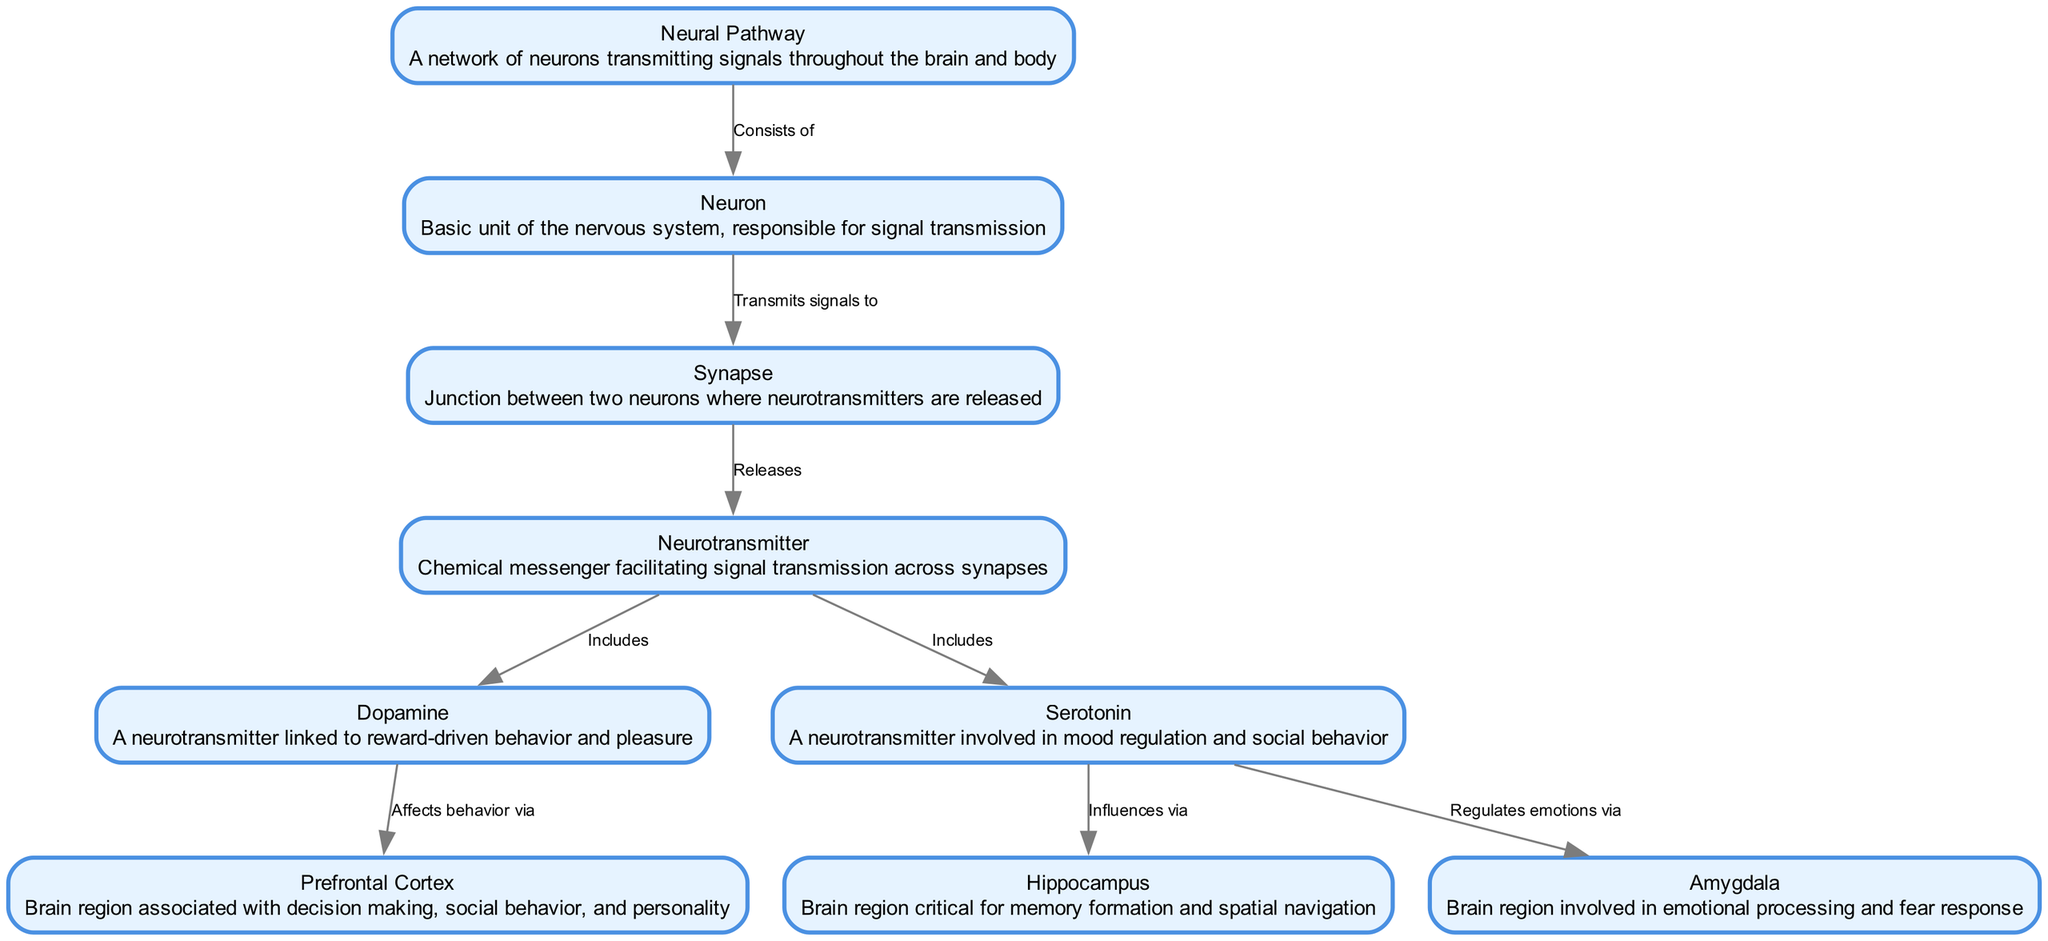What are the types of neurotransmitters mentioned in the diagram? The diagram explicitly lists two neurotransmitters: Dopamine and Serotonin, which are connected to the "Neurotransmitter" node. These are both shown as part of the components that facilitate signal transmission.
Answer: Dopamine, Serotonin How many brain regions are depicted in the diagram? The diagram showcases three brain regions: Hippocampus, Prefrontal Cortex, and Amygdala. Each of these is linked to neurotransmitters and is crucial in regulating different aspects of behavior and emotions.
Answer: 3 What does Dopamine affect according to the diagram? The diagram indicates that Dopamine affects behavior via the Prefrontal Cortex, highlighting its role in decision-making and social interactions. This relationship is shown with a directed edge leading from Dopamine to the Prefrontal Cortex.
Answer: Prefrontal Cortex Which neurotransmitter influences the Hippocampus? The relationship between Serotonin and Hippocampus demonstrates that Serotonin influences this brain region, as indicated by the directed edge in the diagram, which signifies its regulatory effect.
Answer: Serotonin What is the function of the Synapse according to the diagram? The Synapse is described in the diagram as the junction that transmits signals between neurons. It plays a critical role in how neurons communicate with one another, which is pivotal in the functioning of neural pathways.
Answer: Transmits signals How do Serotonin and Amygdala interact in the diagram? The diagram shows that Serotonin regulates emotions through its influence on the Amygdala. The directed edge indicates that Serotonin impacts the emotional processing that occurs within the Amygdala, revealing a specific interaction between these components.
Answer: Regulates emotions How many connections are shown leaving the Neurotransmitter node? The Neurotransmitter node has two connections leading to Dopamine and Serotonin, highlighting the two specific neurotransmitters that are categorized under it for signal transmission roles in the nervous system.
Answer: 2 What role does the Hippocampus play in relation to behavior? The diagram connects the Hippocampus to Serotonin, indicating that the Hippocampus is influenced by Serotonin, which is involved in mood regulation and memory formation, thus associating it with behavioral outcomes in these domains.
Answer: Memory formation Which structural component consists of neurons? The data indicates that the Neural Pathway is the structural component that consists of neurons. It serves as a network through which signals are transmitted, indicating its foundational role in the nervous system.
Answer: Neural Pathway 